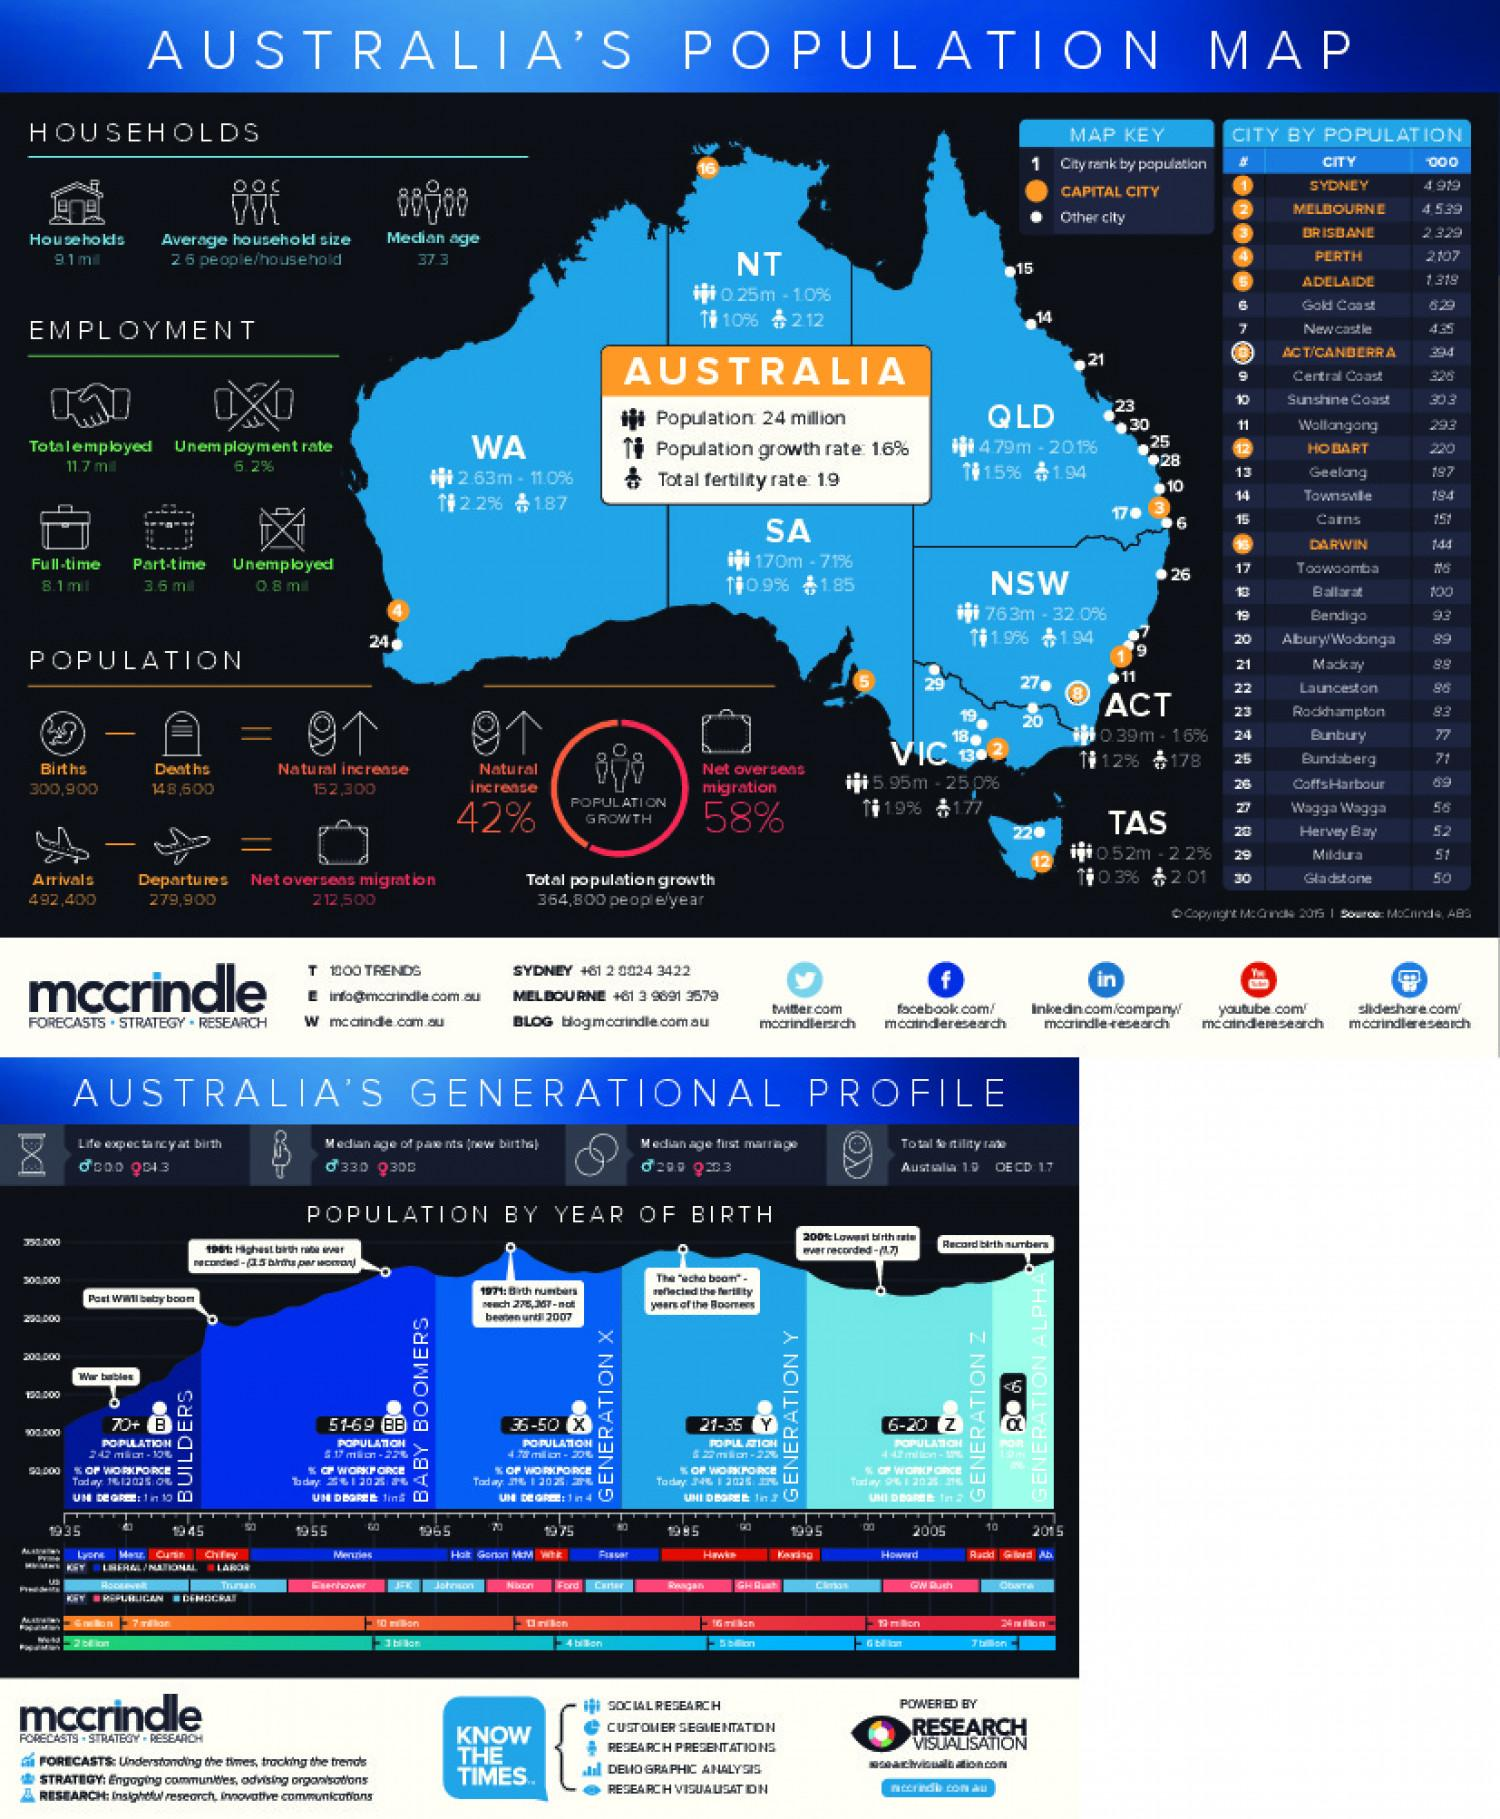Outline some significant characteristics in this image. The capital city of Western Australia is Perth. The total fertility rate in Australia is 1.9 children per woman, as of 2021. The average household size in Australia is 2.6 people per household. Tasmania is the smallest state of Australia, and Hobart is its capital city. Sydney is the highest populated city in Australia. 